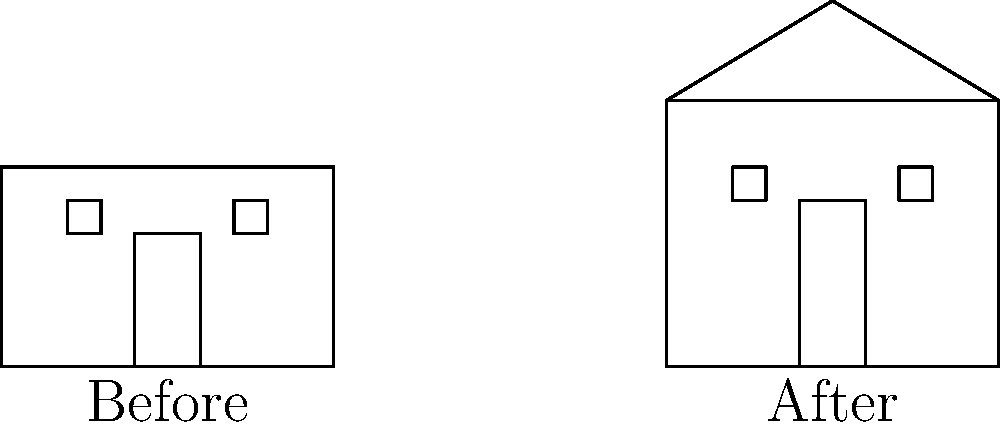As a first-time homebuyer, you're impressed by the before and after sketches of a house facade renovation. The original purchase price was $200,000. If the renovation increased the property value by 40%, what is the estimated value of the house after the renovation? Let's break this down step-by-step:

1. Understand the given information:
   - Original purchase price: $200,000
   - Increase in property value: 40%

2. Calculate the increase in value:
   - 40% of $200,000 = $200,000 × 0.40 = $80,000

3. Add the increase to the original price:
   - New value = Original price + Increase
   - New value = $200,000 + $80,000 = $280,000

The sketches visually represent the improvements made to the house facade, which contribute to the 40% increase in value. As a first-time homebuyer who appreciates staging and attention to detail, you can see how these renovations, such as the added roof pitch and larger windows, have significantly enhanced the property's curb appeal and, consequently, its market value.
Answer: $280,000 